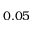Convert formula to latex. <formula><loc_0><loc_0><loc_500><loc_500>0 . 0 5</formula> 